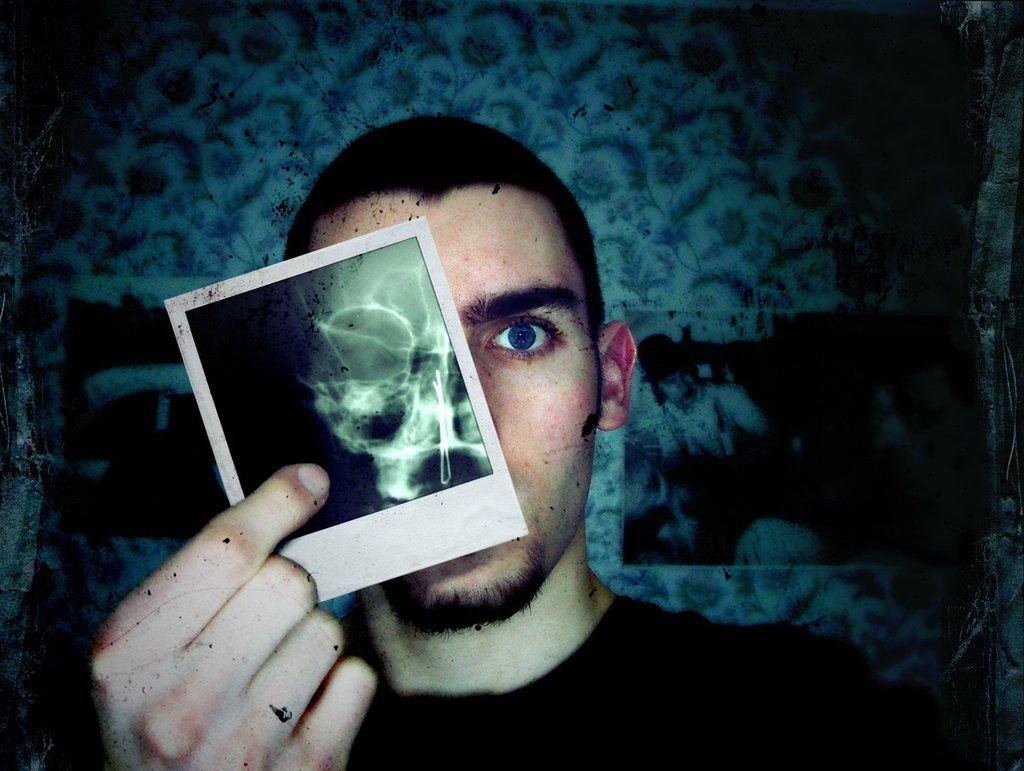What is present in the image? There is a person in the image. What is the person doing in the image? The person is holding an object. What can be seen in the background of the image? There is a wall visible in the image. What is attached to the wall? There are posts on the wall. What type of shade is provided by the flame in the image? There is no flame present in the image, so it cannot provide any shade. 